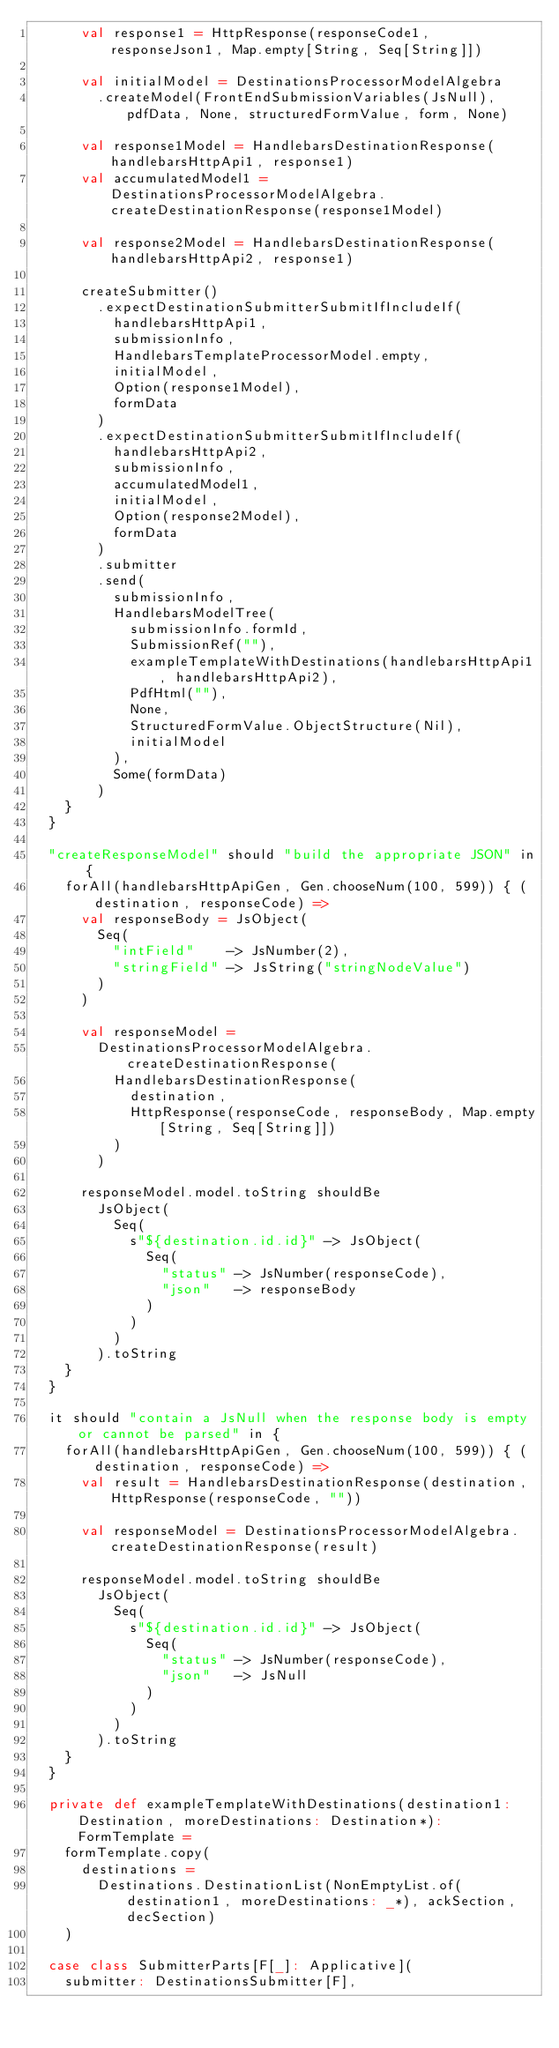Convert code to text. <code><loc_0><loc_0><loc_500><loc_500><_Scala_>      val response1 = HttpResponse(responseCode1, responseJson1, Map.empty[String, Seq[String]])

      val initialModel = DestinationsProcessorModelAlgebra
        .createModel(FrontEndSubmissionVariables(JsNull), pdfData, None, structuredFormValue, form, None)

      val response1Model = HandlebarsDestinationResponse(handlebarsHttpApi1, response1)
      val accumulatedModel1 = DestinationsProcessorModelAlgebra.createDestinationResponse(response1Model)

      val response2Model = HandlebarsDestinationResponse(handlebarsHttpApi2, response1)

      createSubmitter()
        .expectDestinationSubmitterSubmitIfIncludeIf(
          handlebarsHttpApi1,
          submissionInfo,
          HandlebarsTemplateProcessorModel.empty,
          initialModel,
          Option(response1Model),
          formData
        )
        .expectDestinationSubmitterSubmitIfIncludeIf(
          handlebarsHttpApi2,
          submissionInfo,
          accumulatedModel1,
          initialModel,
          Option(response2Model),
          formData
        )
        .submitter
        .send(
          submissionInfo,
          HandlebarsModelTree(
            submissionInfo.formId,
            SubmissionRef(""),
            exampleTemplateWithDestinations(handlebarsHttpApi1, handlebarsHttpApi2),
            PdfHtml(""),
            None,
            StructuredFormValue.ObjectStructure(Nil),
            initialModel
          ),
          Some(formData)
        )
    }
  }

  "createResponseModel" should "build the appropriate JSON" in {
    forAll(handlebarsHttpApiGen, Gen.chooseNum(100, 599)) { (destination, responseCode) =>
      val responseBody = JsObject(
        Seq(
          "intField"    -> JsNumber(2),
          "stringField" -> JsString("stringNodeValue")
        )
      )

      val responseModel =
        DestinationsProcessorModelAlgebra.createDestinationResponse(
          HandlebarsDestinationResponse(
            destination,
            HttpResponse(responseCode, responseBody, Map.empty[String, Seq[String]])
          )
        )

      responseModel.model.toString shouldBe
        JsObject(
          Seq(
            s"${destination.id.id}" -> JsObject(
              Seq(
                "status" -> JsNumber(responseCode),
                "json"   -> responseBody
              )
            )
          )
        ).toString
    }
  }

  it should "contain a JsNull when the response body is empty or cannot be parsed" in {
    forAll(handlebarsHttpApiGen, Gen.chooseNum(100, 599)) { (destination, responseCode) =>
      val result = HandlebarsDestinationResponse(destination, HttpResponse(responseCode, ""))

      val responseModel = DestinationsProcessorModelAlgebra.createDestinationResponse(result)

      responseModel.model.toString shouldBe
        JsObject(
          Seq(
            s"${destination.id.id}" -> JsObject(
              Seq(
                "status" -> JsNumber(responseCode),
                "json"   -> JsNull
              )
            )
          )
        ).toString
    }
  }

  private def exampleTemplateWithDestinations(destination1: Destination, moreDestinations: Destination*): FormTemplate =
    formTemplate.copy(
      destinations =
        Destinations.DestinationList(NonEmptyList.of(destination1, moreDestinations: _*), ackSection, decSection)
    )

  case class SubmitterParts[F[_]: Applicative](
    submitter: DestinationsSubmitter[F],</code> 